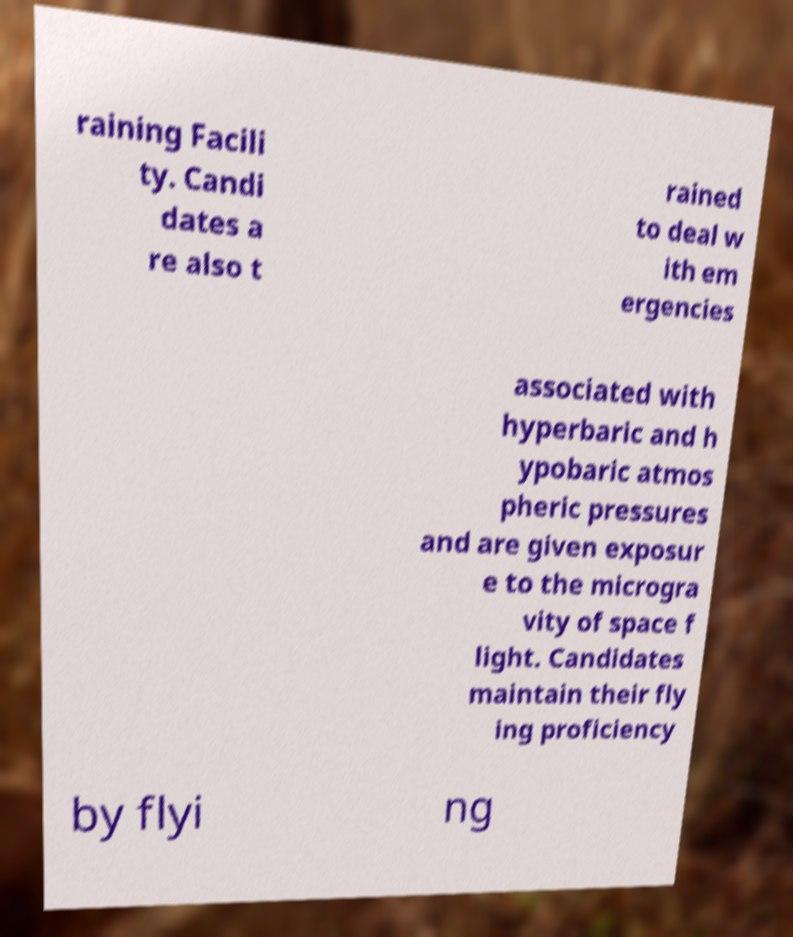Can you read and provide the text displayed in the image?This photo seems to have some interesting text. Can you extract and type it out for me? raining Facili ty. Candi dates a re also t rained to deal w ith em ergencies associated with hyperbaric and h ypobaric atmos pheric pressures and are given exposur e to the microgra vity of space f light. Candidates maintain their fly ing proficiency by flyi ng 